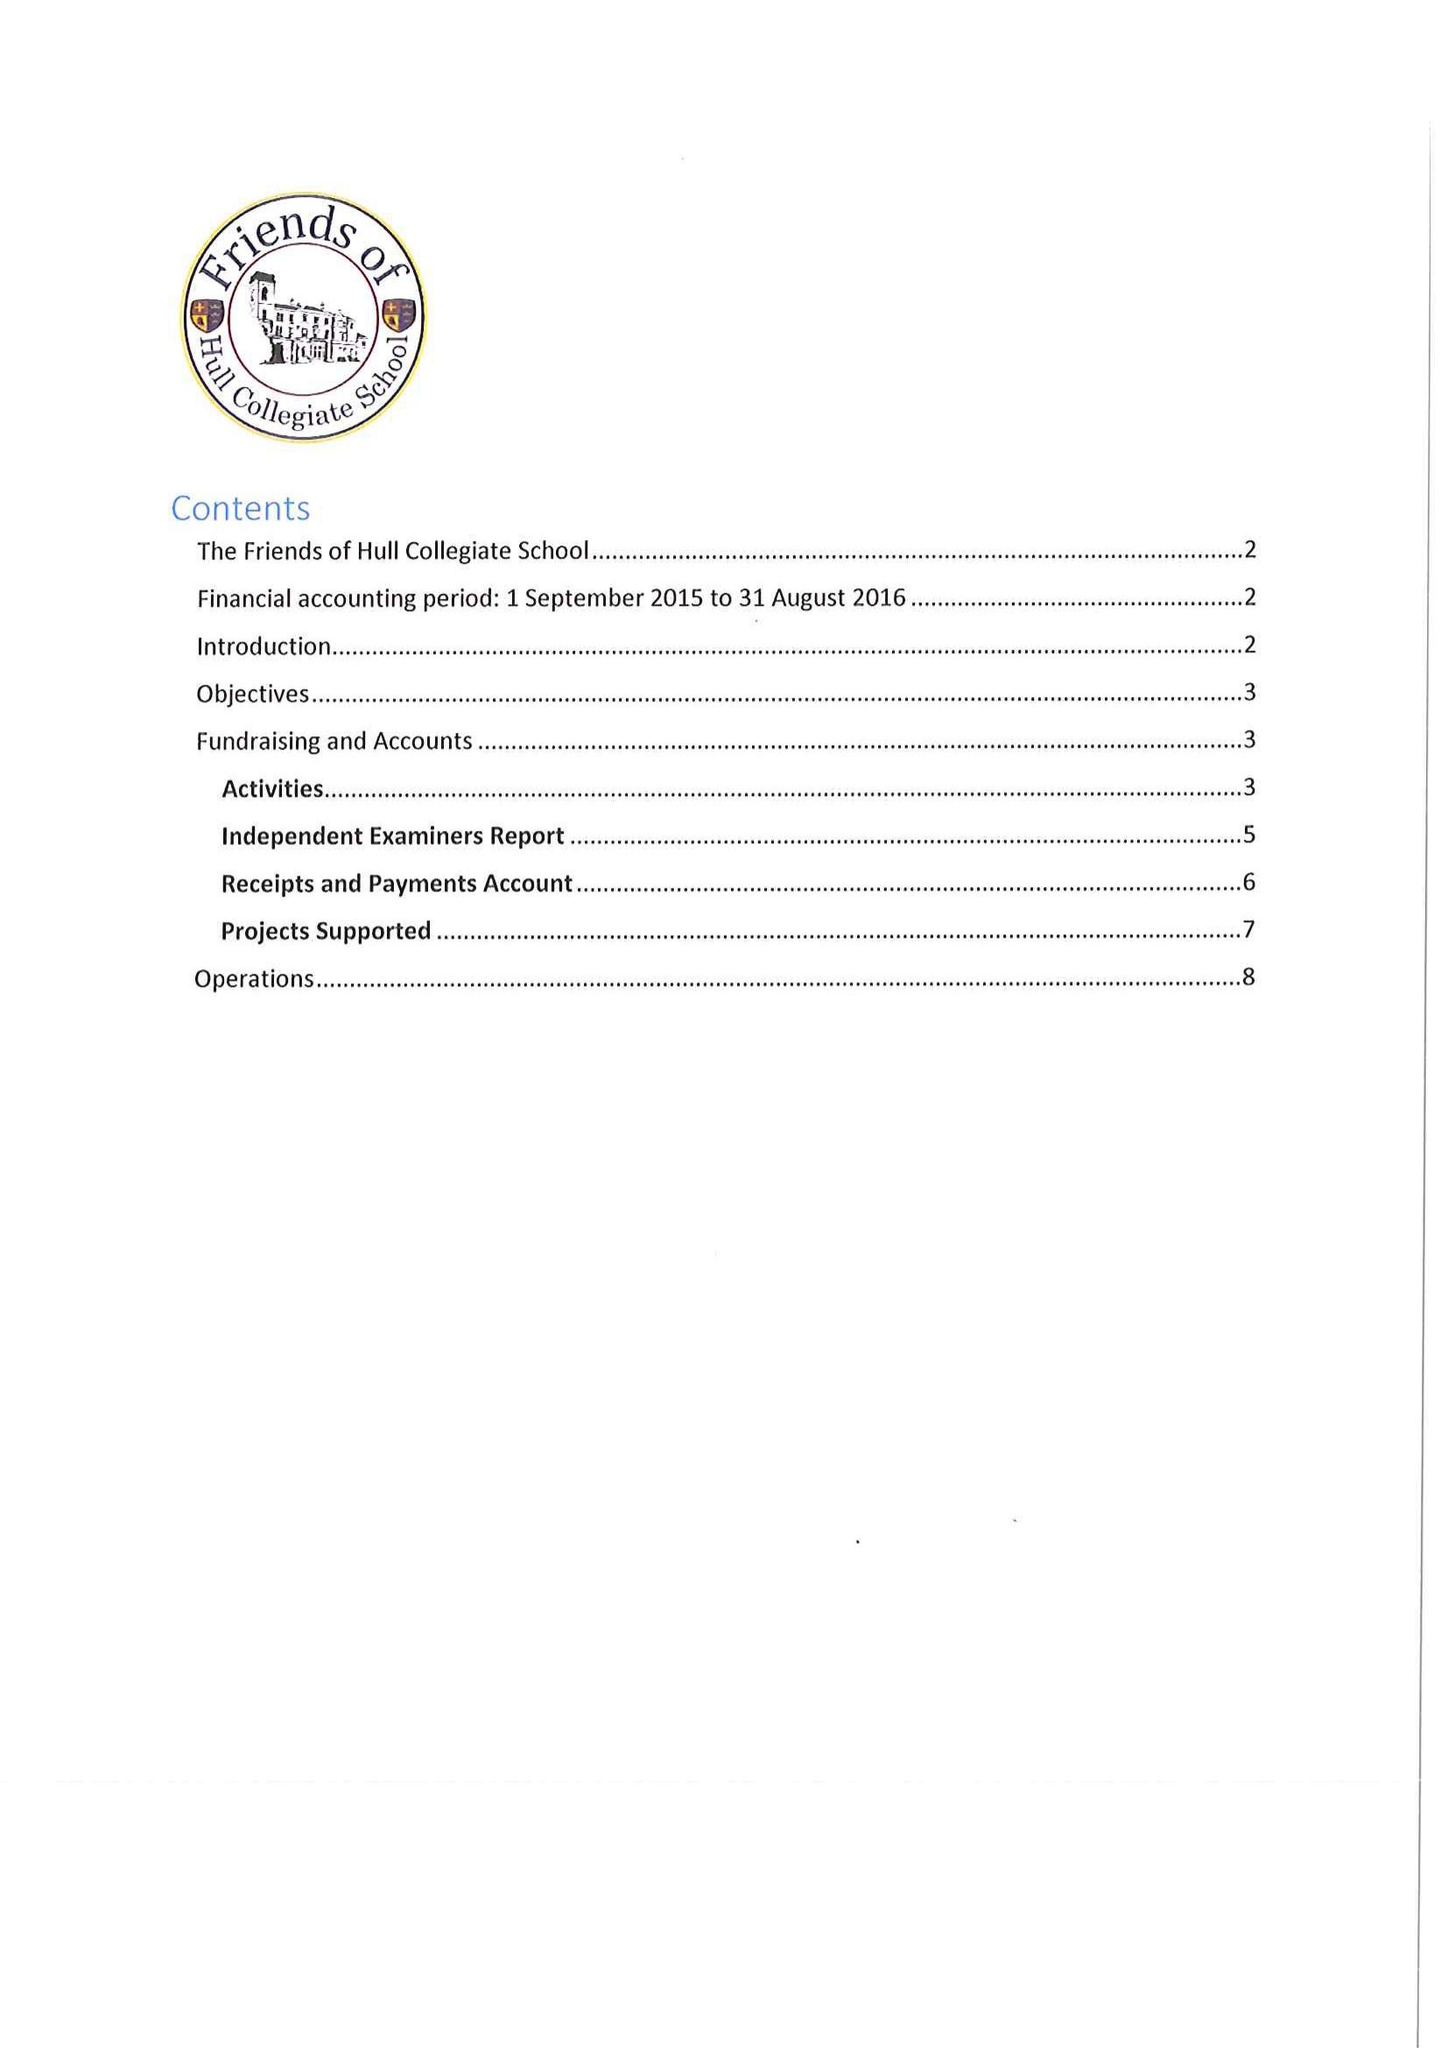What is the value for the charity_number?
Answer the question using a single word or phrase. 509193 